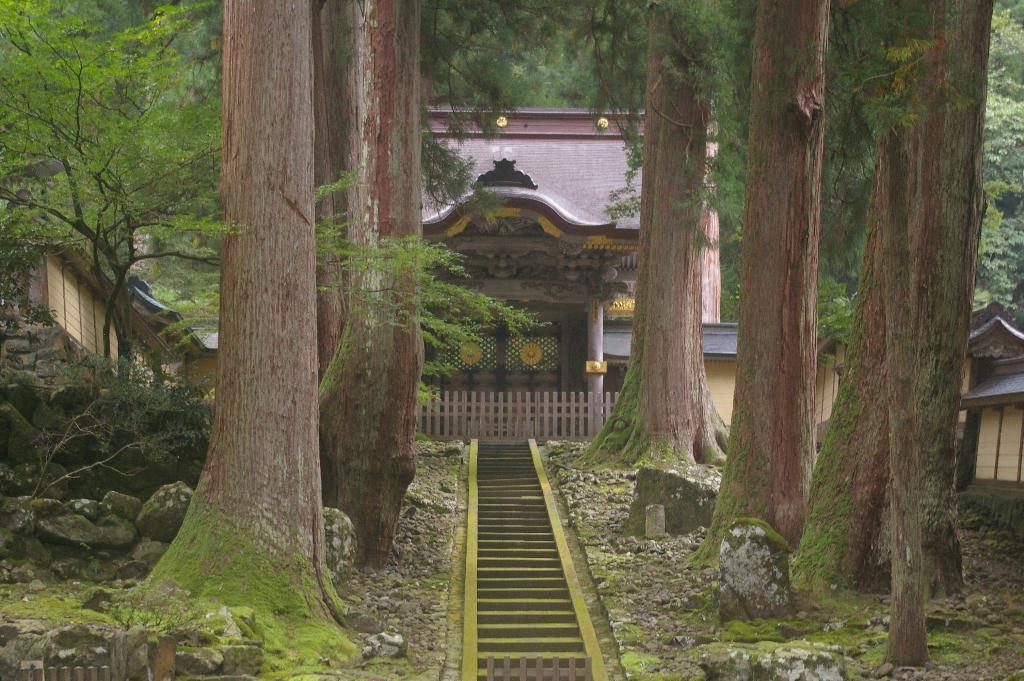What type of vegetation is present in the image? There are tall trees in the image. What can be seen between the trees? There is a path between the trees. What structure is located near the path? There is a house in front of the path. What type of furniture is visible in the image? There is no furniture present in the image. What shape is the house in the image? The shape of the house is not mentioned in the provided facts, so it cannot be determined from the image. 